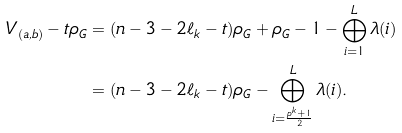<formula> <loc_0><loc_0><loc_500><loc_500>V _ { ( a , b ) } - t \rho _ { G } & = ( n - 3 - 2 \ell _ { k } - t ) \rho _ { G } + \rho _ { G } - 1 - \bigoplus _ { i = 1 } ^ { L } \lambda ( i ) \\ & = ( n - 3 - 2 \ell _ { k } - t ) \rho _ { G } - \bigoplus _ { i = \frac { p ^ { k } + 1 } { 2 } } ^ { L } \lambda ( i ) .</formula> 